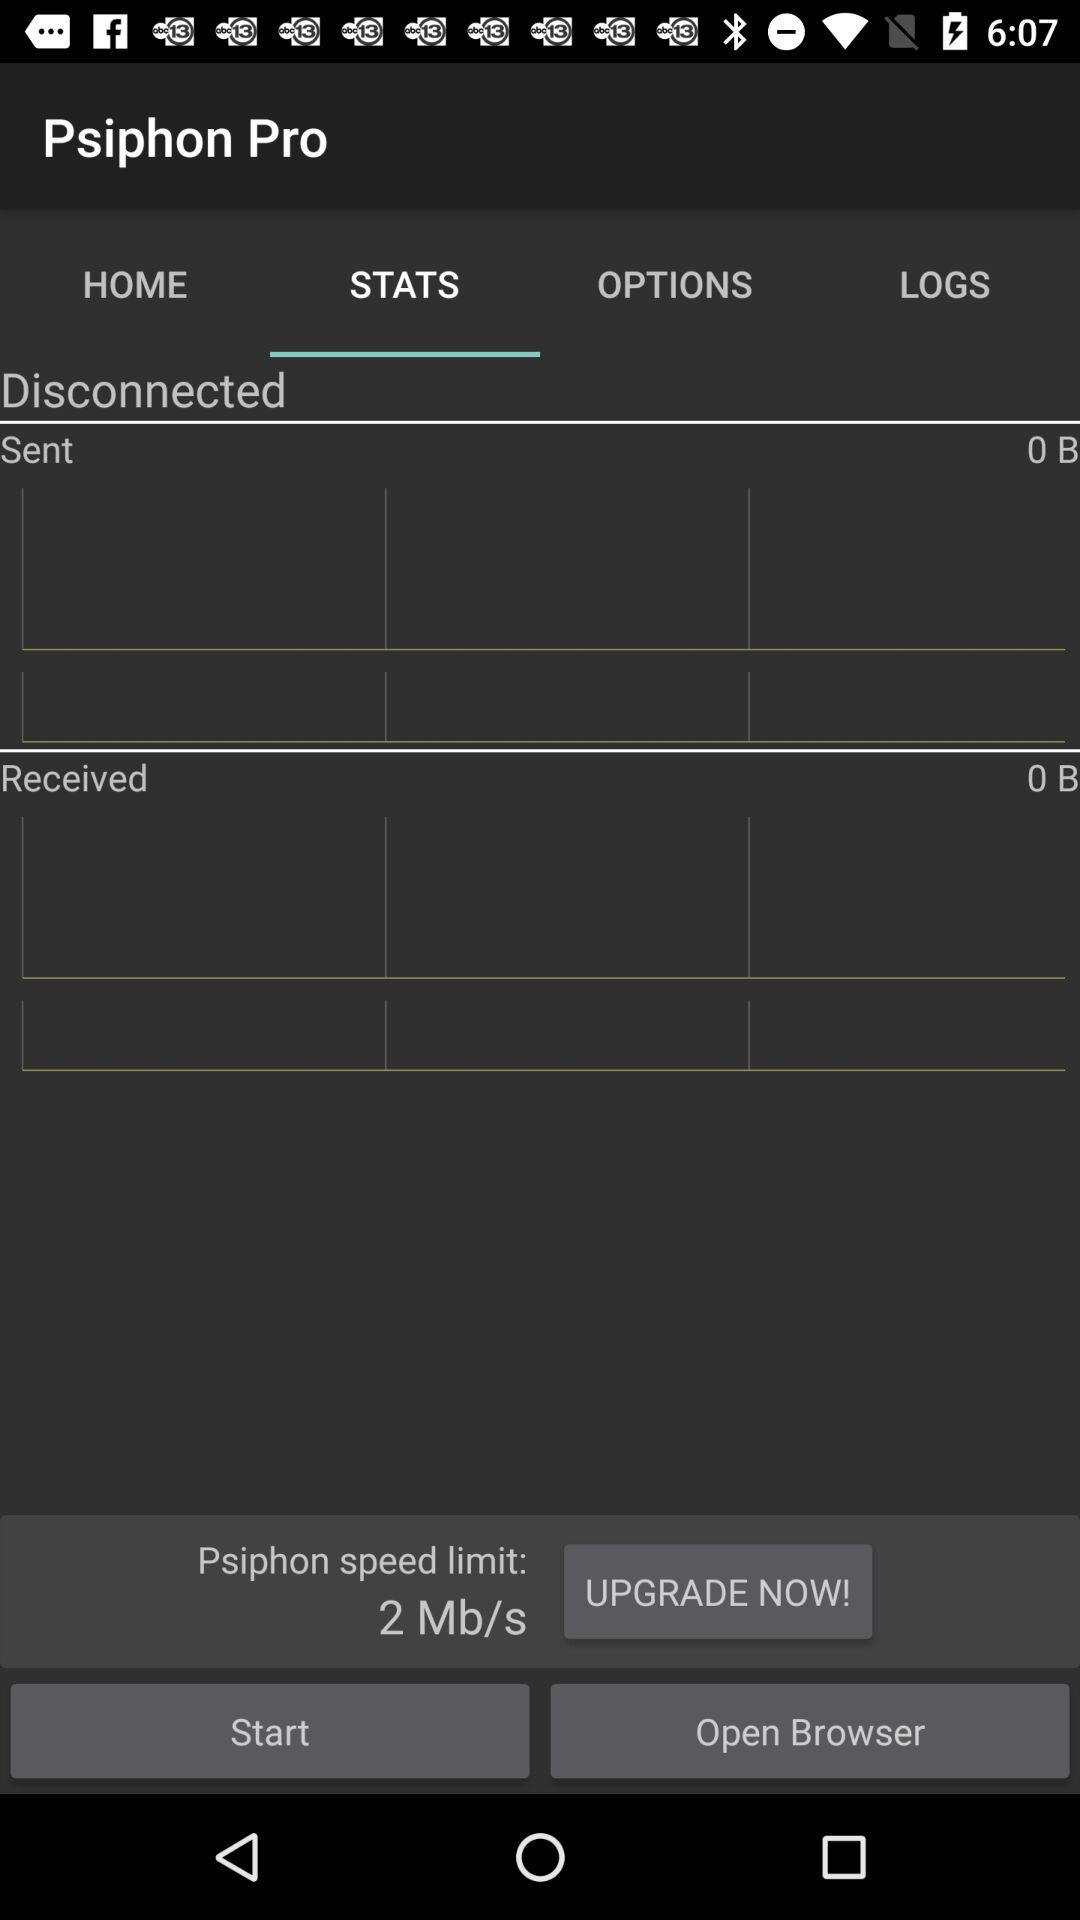How much data have I sent?
Answer the question using a single word or phrase. 0 B 